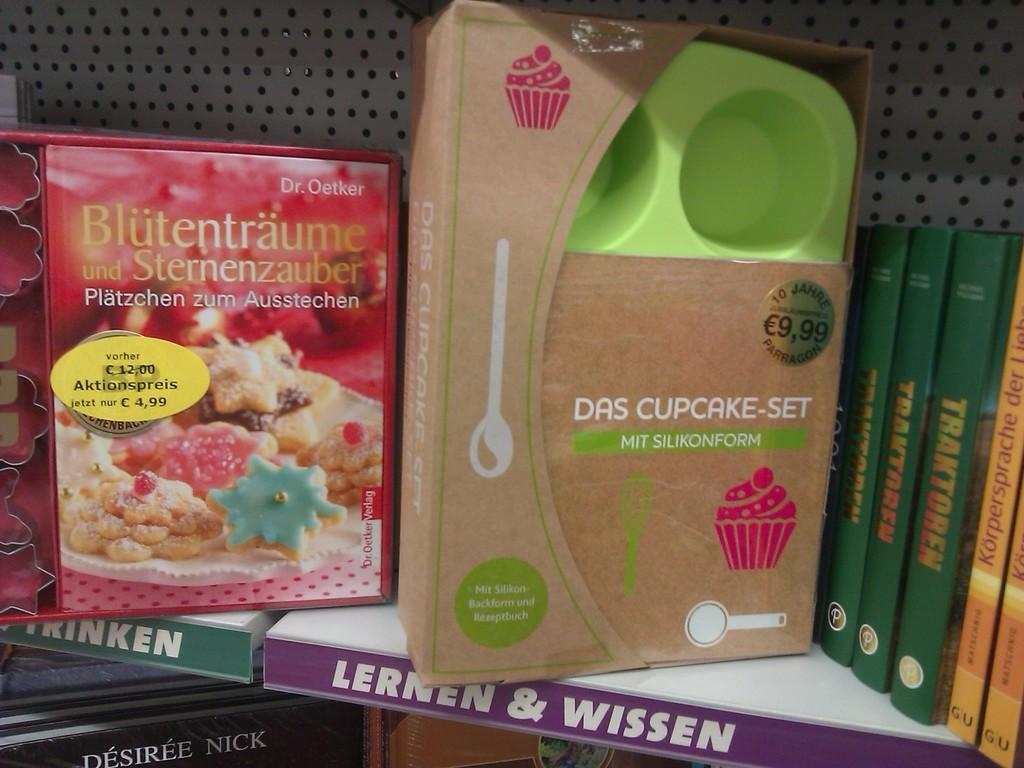Provide a one-sentence caption for the provided image. A shelf that displays a German cookbook for desserts and a cupcake baking set. 